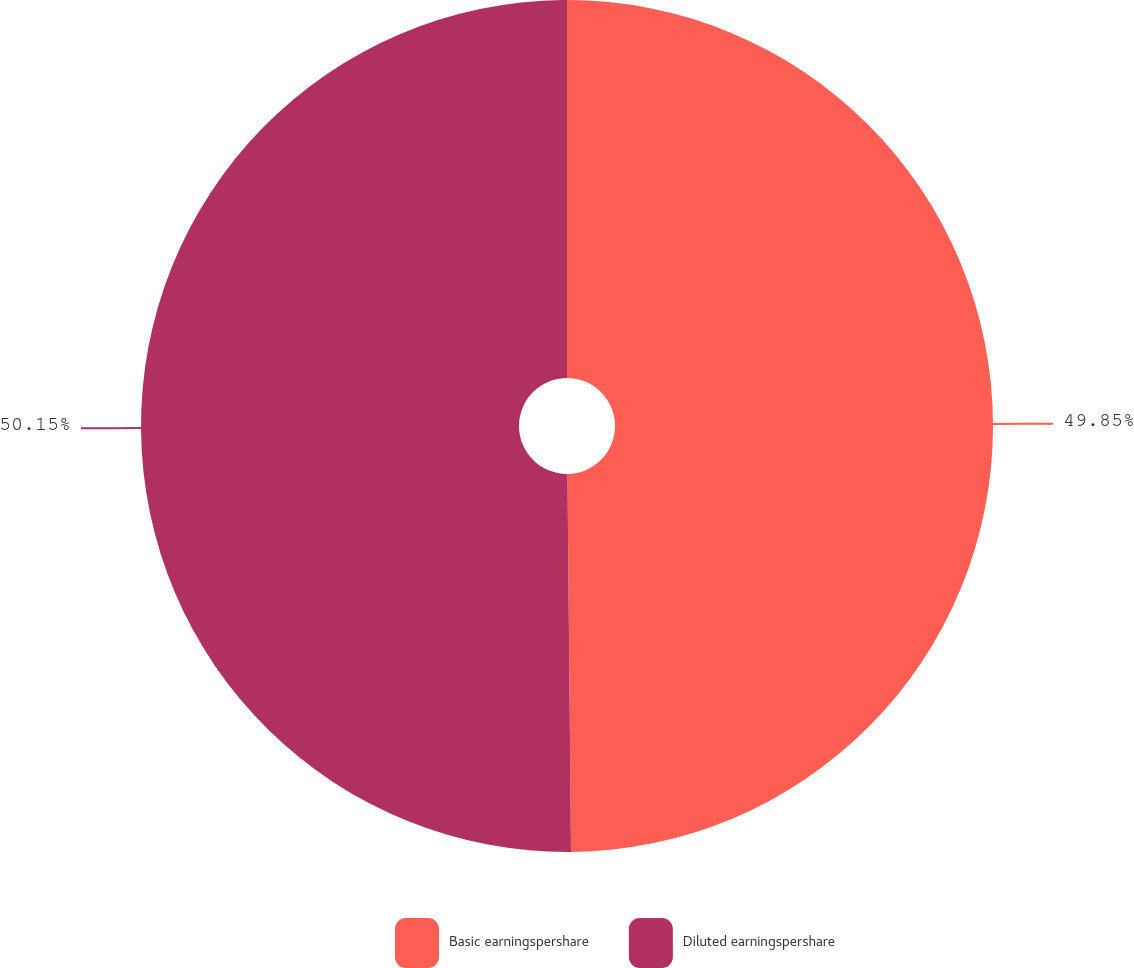Convert chart to OTSL. <chart><loc_0><loc_0><loc_500><loc_500><pie_chart><fcel>Basic earningspershare<fcel>Diluted earningspershare<nl><fcel>49.85%<fcel>50.15%<nl></chart> 